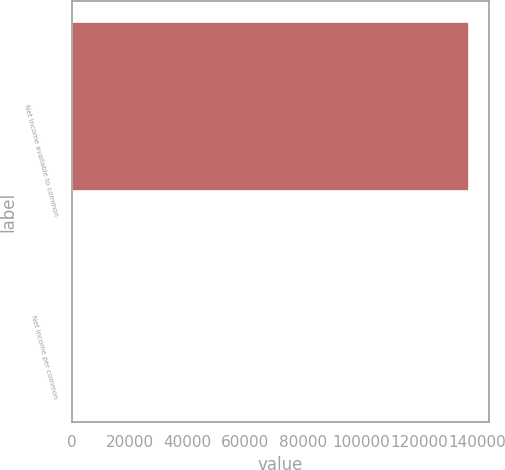Convert chart. <chart><loc_0><loc_0><loc_500><loc_500><bar_chart><fcel>Net income available to common<fcel>Net income per common<nl><fcel>137425<fcel>1.89<nl></chart> 